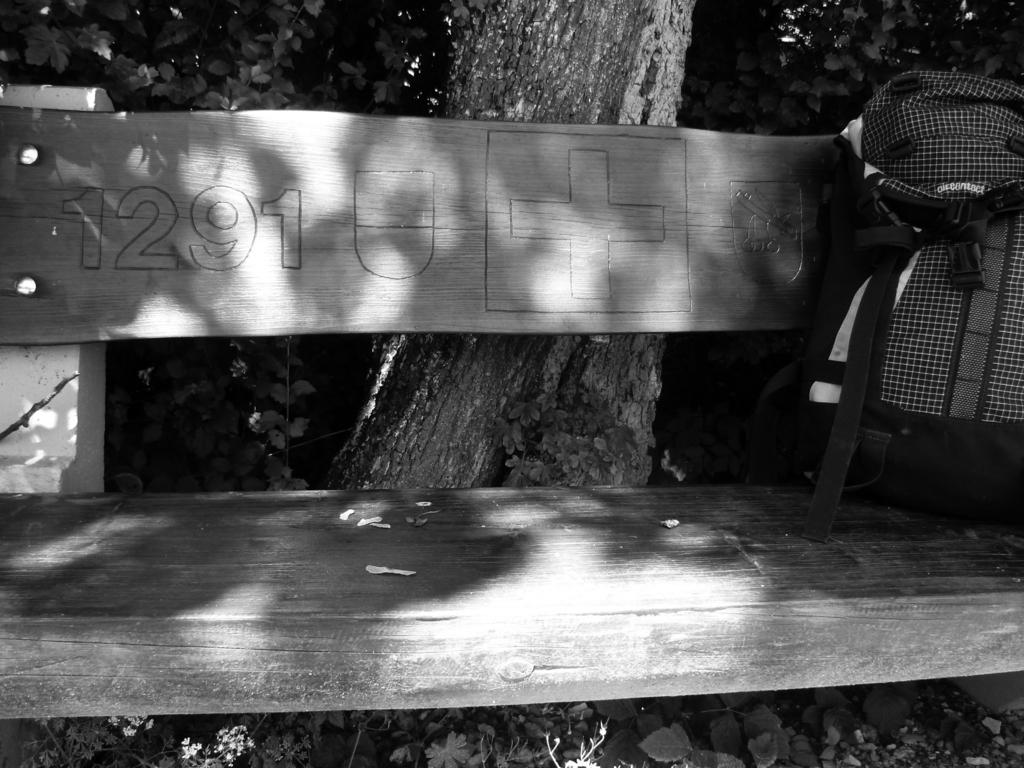What type of seating is visible in the image? There is a wooden bench in the image. What is placed on the wooden bench? There is an object on the bench. What can be seen in the background of the image? There is a tree and plants in the background of the image. What is the color scheme of the image? The image is black and white in color. What type of route is visible in the image? There is no route visible in the image; it only features a wooden bench, an object on the bench, and background elements. How many bushes are present in the image? There is no mention of bushes in the provided facts, so we cannot determine their presence or quantity in the image. 